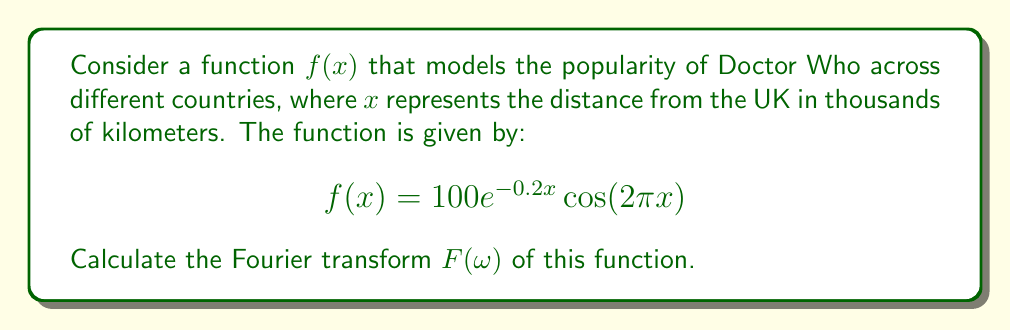Give your solution to this math problem. To solve this problem, we'll follow these steps:

1) The Fourier transform of a function $f(x)$ is defined as:

   $$F(\omega) = \int_{-\infty}^{\infty} f(x)e^{-i\omega x}dx$$

2) Substituting our given function:

   $$F(\omega) = \int_{-\infty}^{\infty} 100e^{-0.2x}\cos(2\pi x)e^{-i\omega x}dx$$

3) Using Euler's formula, we can write $\cos(2\pi x)$ as:

   $$\cos(2\pi x) = \frac{e^{i2\pi x} + e^{-i2\pi x}}{2}$$

4) Substituting this into our integral:

   $$F(\omega) = 50\int_{-\infty}^{\infty} e^{-0.2x}(e^{i2\pi x} + e^{-i2\pi x})e^{-i\omega x}dx$$

5) Distributing the $e^{-i\omega x}$:

   $$F(\omega) = 50\int_{-\infty}^{\infty} e^{-0.2x}(e^{i(2\pi-\omega)x} + e^{-i(2\pi+\omega)x})dx$$

6) This can be split into two integrals:

   $$F(\omega) = 50\int_{-\infty}^{\infty} e^{-(0.2-i(2\pi-\omega))x}dx + 50\int_{-\infty}^{\infty} e^{-(0.2+i(2\pi+\omega))x}dx$$

7) The general form of these integrals is $\int_{-\infty}^{\infty} e^{-ax}dx = \frac{2}{a}$ for $Re(a) > 0$

8) Applying this to our integrals:

   $$F(\omega) = \frac{100}{0.2-i(2\pi-\omega)} + \frac{100}{0.2+i(2\pi+\omega)}$$

9) Simplifying:

   $$F(\omega) = \frac{100(0.2+i(2\pi-\omega))}{0.04+(2\pi-\omega)^2} + \frac{100(0.2-i(2\pi+\omega))}{0.04+(2\pi+\omega)^2}$$

This is the Fourier transform of the given function.
Answer: $$F(\omega) = \frac{100(0.2+i(2\pi-\omega))}{0.04+(2\pi-\omega)^2} + \frac{100(0.2-i(2\pi+\omega))}{0.04+(2\pi+\omega)^2}$$ 